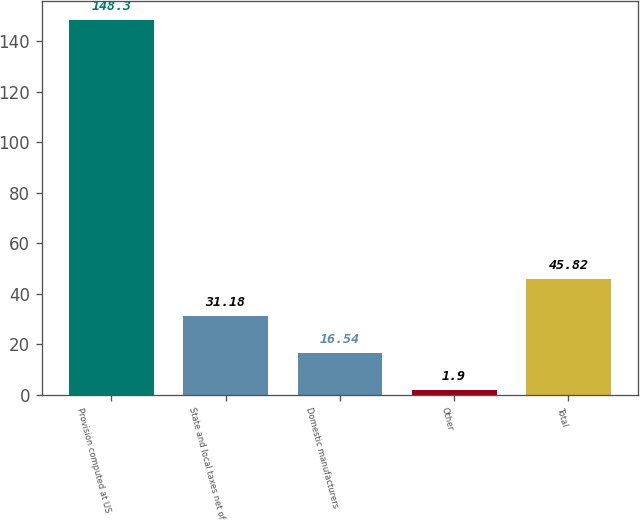<chart> <loc_0><loc_0><loc_500><loc_500><bar_chart><fcel>Provision computed at US<fcel>State and local taxes net of<fcel>Domestic manufacturers<fcel>Other<fcel>Total<nl><fcel>148.3<fcel>31.18<fcel>16.54<fcel>1.9<fcel>45.82<nl></chart> 